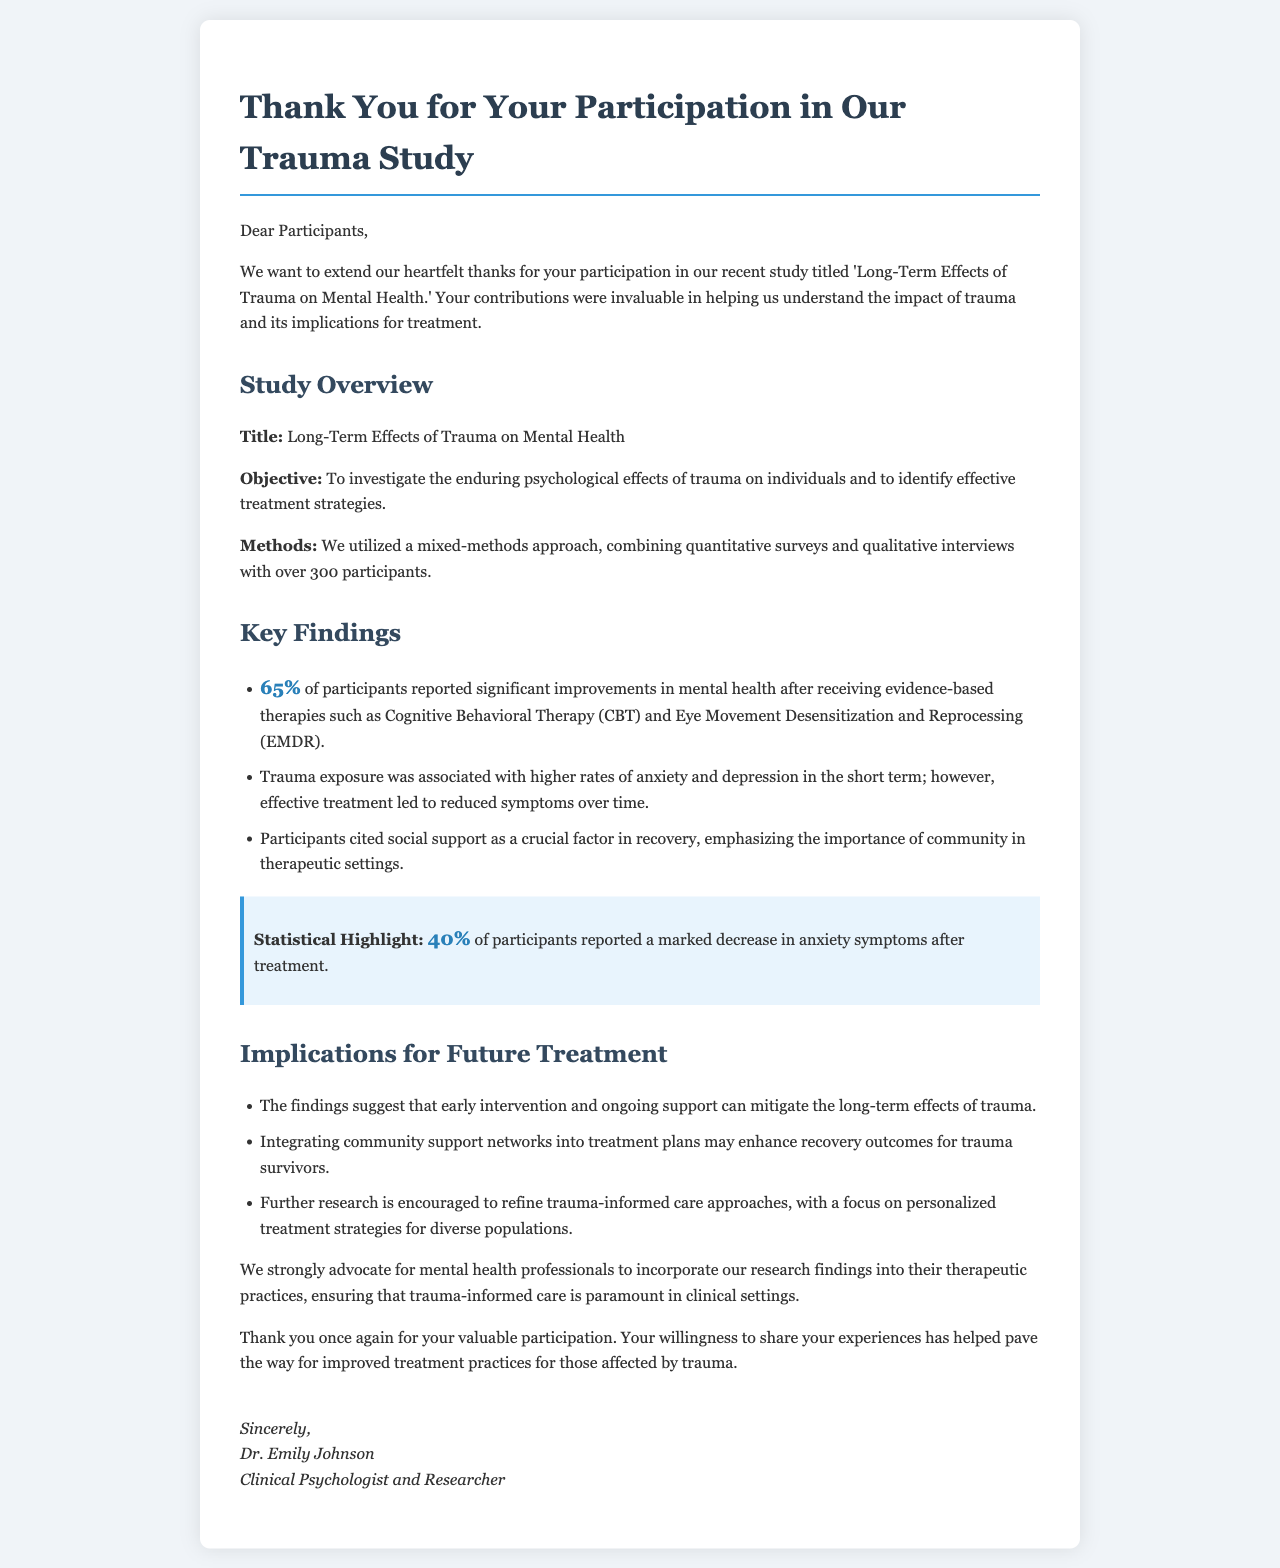what is the title of the study? The title of the study is explicitly mentioned at the beginning of the study overview section.
Answer: Long-Term Effects of Trauma on Mental Health how many participants were involved in the study? The document states that over 300 participants were involved in the study, which can be found in the methods section.
Answer: over 300 what percentage of participants reported significant improvements after treatment? The document lists a statistic highlighting that a specific percentage of participants reported improvements, located in the key findings section.
Answer: 65% what treatment methods were highlighted in the study? The document mentions specific therapies that were used in the study in the key findings section, which includes well-known treatment methods.
Answer: Cognitive Behavioral Therapy (CBT) and Eye Movement Desensitization and Reprocessing (EMDR) what was the impact of social support according to participants? The document describes the role of social support based on participant feedback, indicating its importance during recovery, found in the key findings section.
Answer: crucial factor in recovery what does the document suggest about community support networks? The findings in the implications for future treatment section emphasize the need for a specific type of network in treatment plans.
Answer: enhance recovery outcomes who is the author of the letter? The author is mentioned at the end of the document within the signature area and identifies themself clearly.
Answer: Dr. Emily Johnson what is the primary objective of the study? The document outlines the primary goal of the study in the study overview section, which reflects its intended research focus.
Answer: investigate the enduring psychological effects of trauma what percentage reported a marked decrease in anxiety symptoms? A specific percentage is highlighted in a statistical highlight section, showing its importance in the study results.
Answer: 40% 